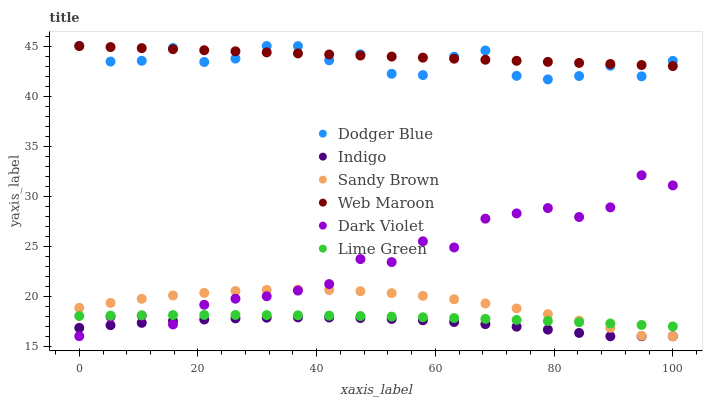Does Indigo have the minimum area under the curve?
Answer yes or no. Yes. Does Web Maroon have the maximum area under the curve?
Answer yes or no. Yes. Does Lime Green have the minimum area under the curve?
Answer yes or no. No. Does Lime Green have the maximum area under the curve?
Answer yes or no. No. Is Web Maroon the smoothest?
Answer yes or no. Yes. Is Dark Violet the roughest?
Answer yes or no. Yes. Is Lime Green the smoothest?
Answer yes or no. No. Is Lime Green the roughest?
Answer yes or no. No. Does Indigo have the lowest value?
Answer yes or no. Yes. Does Lime Green have the lowest value?
Answer yes or no. No. Does Dodger Blue have the highest value?
Answer yes or no. Yes. Does Lime Green have the highest value?
Answer yes or no. No. Is Indigo less than Web Maroon?
Answer yes or no. Yes. Is Dodger Blue greater than Dark Violet?
Answer yes or no. Yes. Does Web Maroon intersect Dodger Blue?
Answer yes or no. Yes. Is Web Maroon less than Dodger Blue?
Answer yes or no. No. Is Web Maroon greater than Dodger Blue?
Answer yes or no. No. Does Indigo intersect Web Maroon?
Answer yes or no. No. 